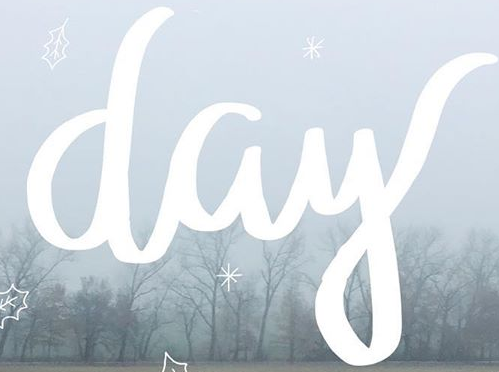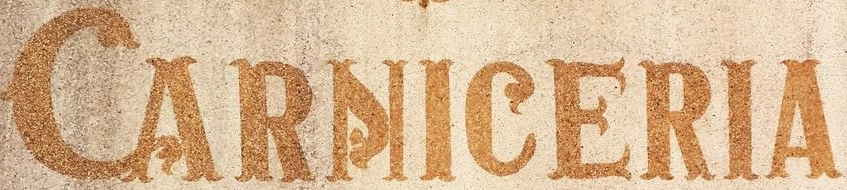What words are shown in these images in order, separated by a semicolon? day; CARNICERIA 